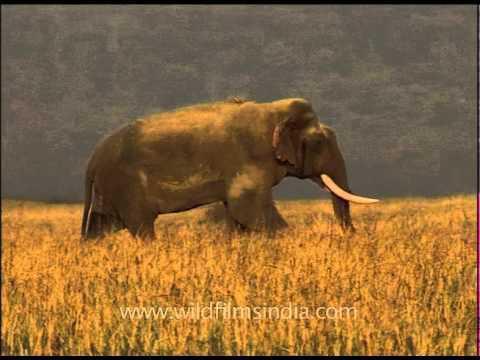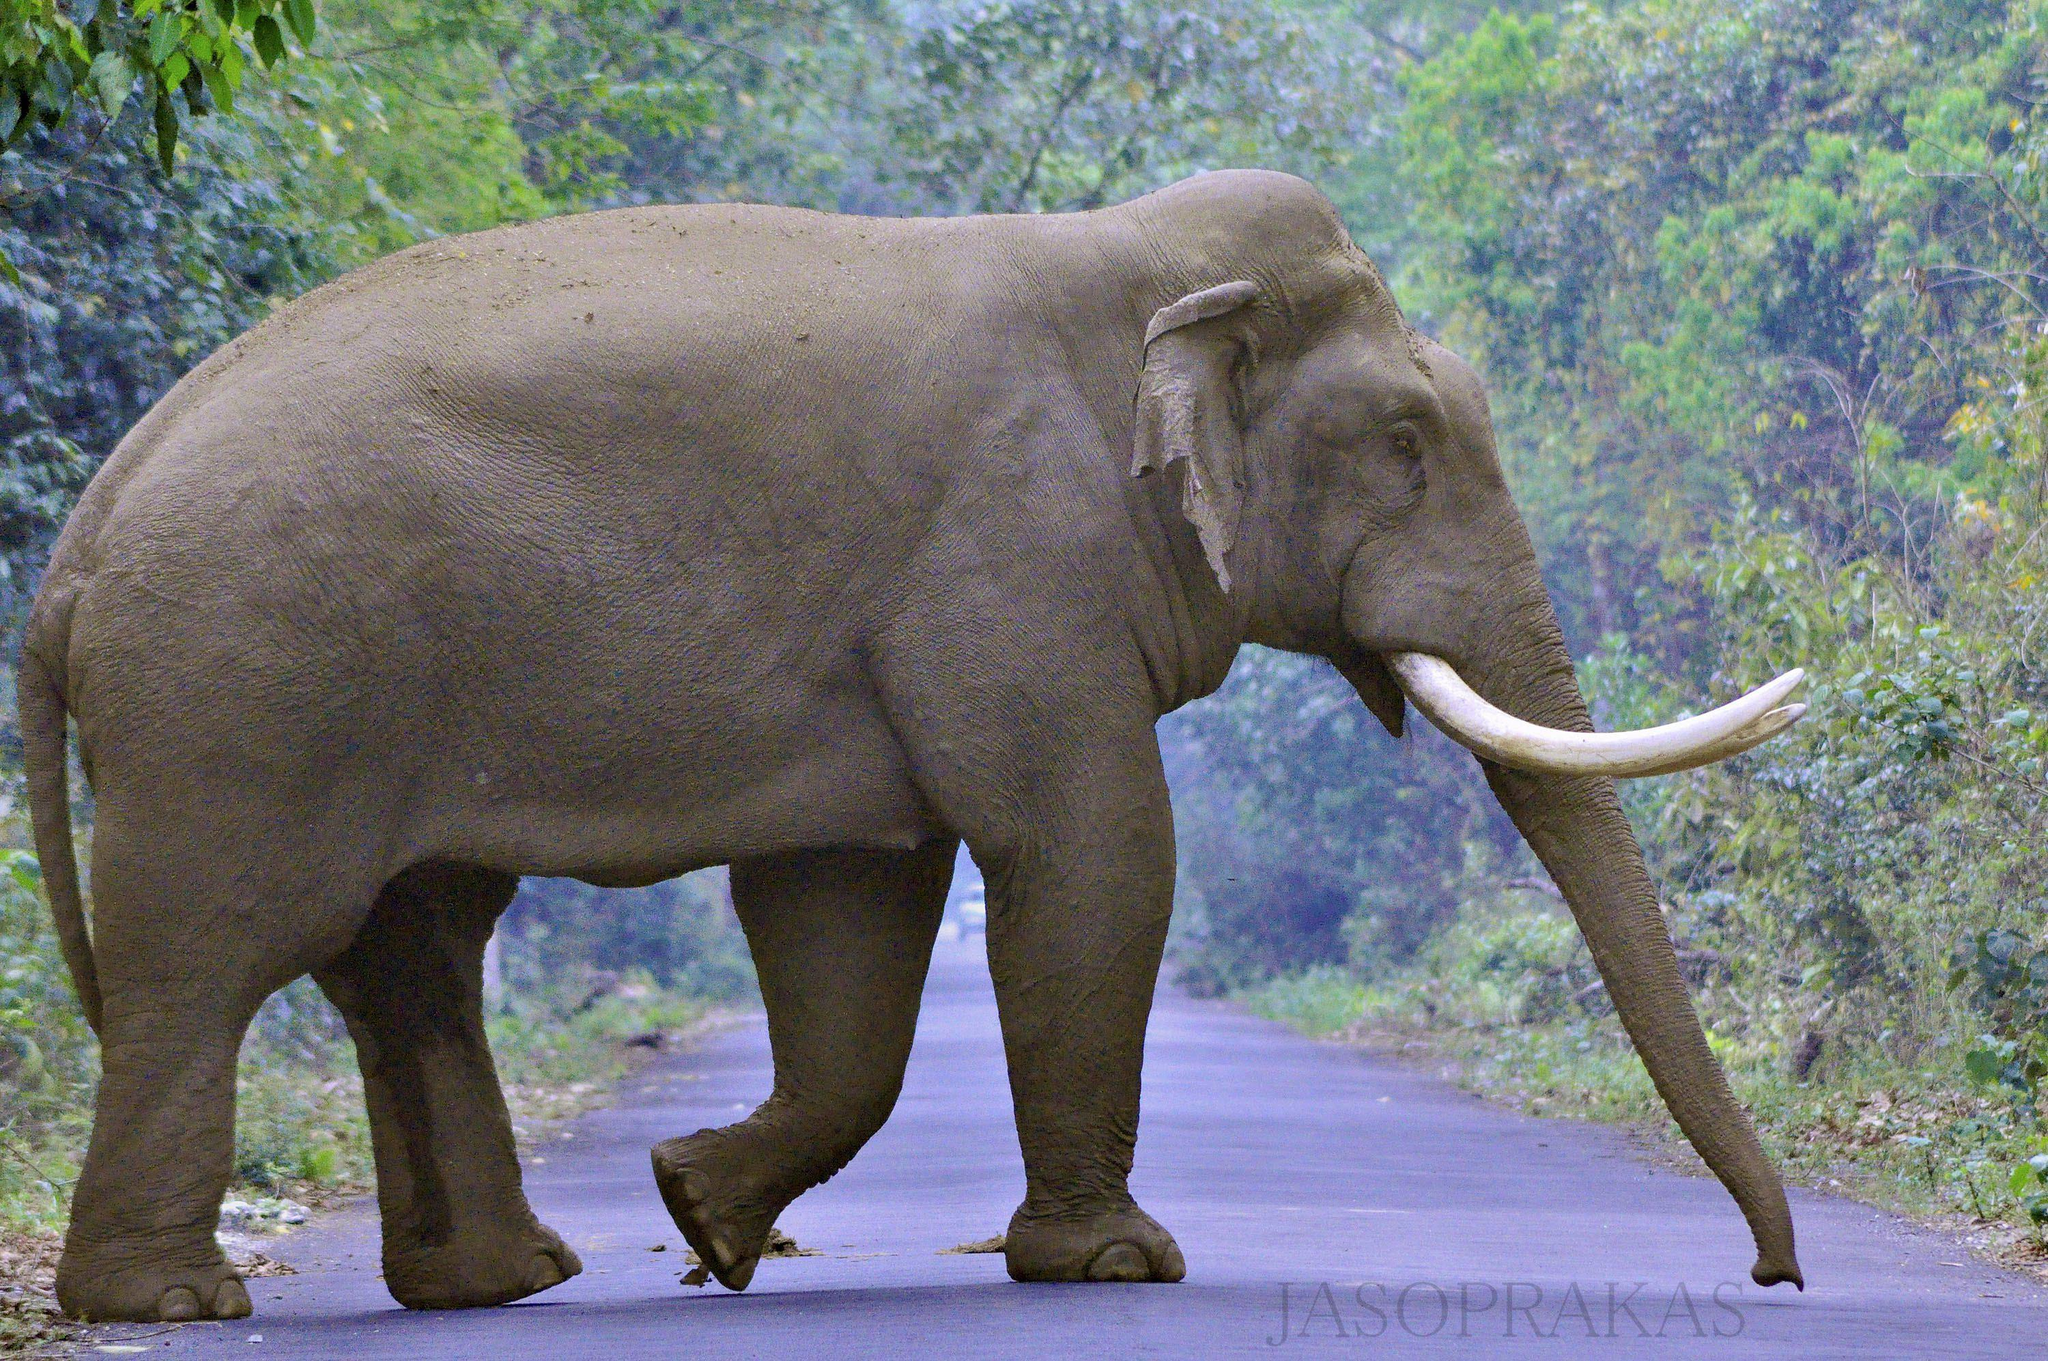The first image is the image on the left, the second image is the image on the right. Considering the images on both sides, is "At baby elephant is near at least 1 other grown elephant." valid? Answer yes or no. No. 